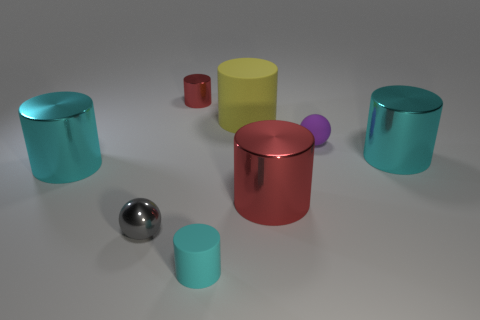Can you describe the arrangement and colors of the objects present in the image? Certainly! The image presents a collection of cylindrical and spherical objects arranged seemingly at random on a flat surface. In terms of color, we observe cylinders in aqua blue, red, yellowish-green, and teal. There's also a small red cylinder and two spheres – one large and shiny gray, and another much smaller, in purple. 